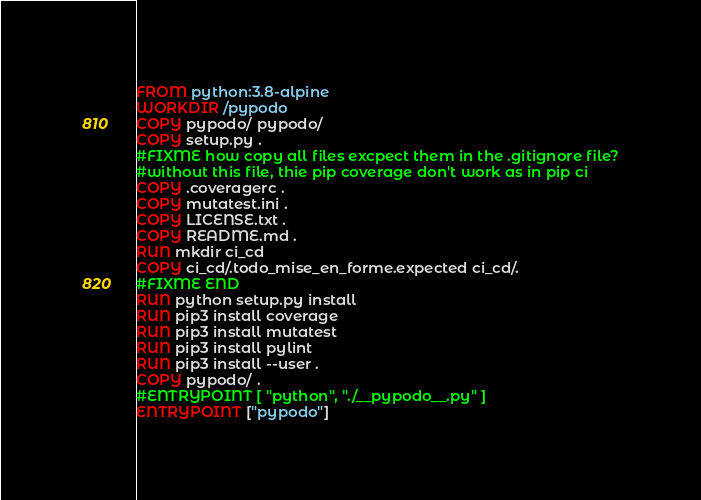Convert code to text. <code><loc_0><loc_0><loc_500><loc_500><_Dockerfile_>FROM python:3.8-alpine 
WORKDIR /pypodo
COPY pypodo/ pypodo/
COPY setup.py .
#FIXME how copy all files excpect them in the .gitignore file?
#without this file, thie pip coverage don't work as in pip ci
COPY .coveragerc .
COPY mutatest.ini .
COPY LICENSE.txt .
COPY README.md .
RUN mkdir ci_cd
COPY ci_cd/.todo_mise_en_forme.expected ci_cd/.
#FIXME END
RUN python setup.py install
RUN pip3 install coverage
RUN pip3 install mutatest
RUN pip3 install pylint
RUN pip3 install --user .
COPY pypodo/ .
#ENTRYPOINT [ "python", "./__pypodo__.py" ]
ENTRYPOINT ["pypodo"]</code> 